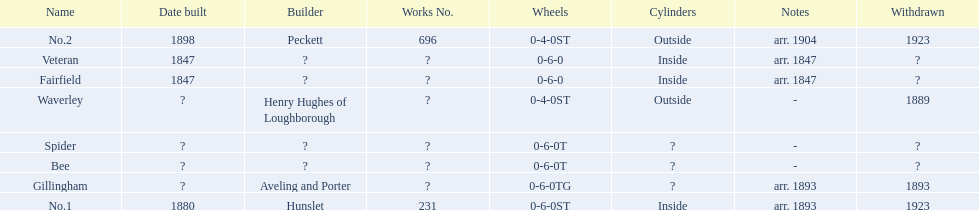What name comes next fairfield? Waverley. Could you parse the entire table as a dict? {'header': ['Name', 'Date built', 'Builder', 'Works No.', 'Wheels', 'Cylinders', 'Notes', 'Withdrawn'], 'rows': [['No.2', '1898', 'Peckett', '696', '0-4-0ST', 'Outside', 'arr. 1904', '1923'], ['Veteran', '1847', '?', '?', '0-6-0', 'Inside', 'arr. 1847', '?'], ['Fairfield', '1847', '?', '?', '0-6-0', 'Inside', 'arr. 1847', '?'], ['Waverley', '?', 'Henry Hughes of Loughborough', '?', '0-4-0ST', 'Outside', '-', '1889'], ['Spider', '?', '?', '?', '0-6-0T', '?', '-', '?'], ['Bee', '?', '?', '?', '0-6-0T', '?', '-', '?'], ['Gillingham', '?', 'Aveling and Porter', '?', '0-6-0TG', '?', 'arr. 1893', '1893'], ['No.1', '1880', 'Hunslet', '231', '0-6-0ST', 'Inside', 'arr. 1893', '1923']]} 